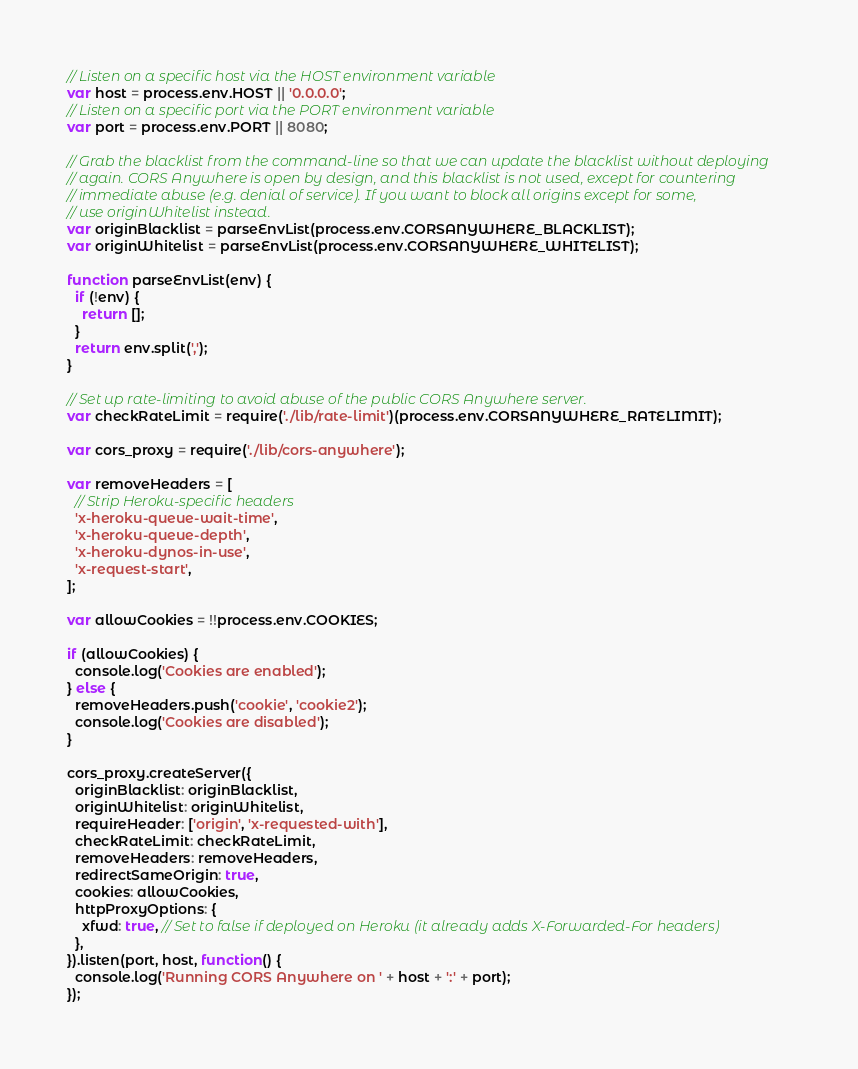<code> <loc_0><loc_0><loc_500><loc_500><_JavaScript_>// Listen on a specific host via the HOST environment variable
var host = process.env.HOST || '0.0.0.0';
// Listen on a specific port via the PORT environment variable
var port = process.env.PORT || 8080;

// Grab the blacklist from the command-line so that we can update the blacklist without deploying
// again. CORS Anywhere is open by design, and this blacklist is not used, except for countering
// immediate abuse (e.g. denial of service). If you want to block all origins except for some,
// use originWhitelist instead.
var originBlacklist = parseEnvList(process.env.CORSANYWHERE_BLACKLIST);
var originWhitelist = parseEnvList(process.env.CORSANYWHERE_WHITELIST);

function parseEnvList(env) {
  if (!env) {
    return [];
  }
  return env.split(',');
}

// Set up rate-limiting to avoid abuse of the public CORS Anywhere server.
var checkRateLimit = require('./lib/rate-limit')(process.env.CORSANYWHERE_RATELIMIT);

var cors_proxy = require('./lib/cors-anywhere');

var removeHeaders = [
  // Strip Heroku-specific headers
  'x-heroku-queue-wait-time',
  'x-heroku-queue-depth',
  'x-heroku-dynos-in-use',
  'x-request-start',
];

var allowCookies = !!process.env.COOKIES;

if (allowCookies) {
  console.log('Cookies are enabled');
} else {
  removeHeaders.push('cookie', 'cookie2');
  console.log('Cookies are disabled');
}

cors_proxy.createServer({
  originBlacklist: originBlacklist,
  originWhitelist: originWhitelist,
  requireHeader: ['origin', 'x-requested-with'],
  checkRateLimit: checkRateLimit,
  removeHeaders: removeHeaders,
  redirectSameOrigin: true,
  cookies: allowCookies,
  httpProxyOptions: {
    xfwd: true, // Set to false if deployed on Heroku (it already adds X-Forwarded-For headers)
  },
}).listen(port, host, function() {
  console.log('Running CORS Anywhere on ' + host + ':' + port);
});
</code> 